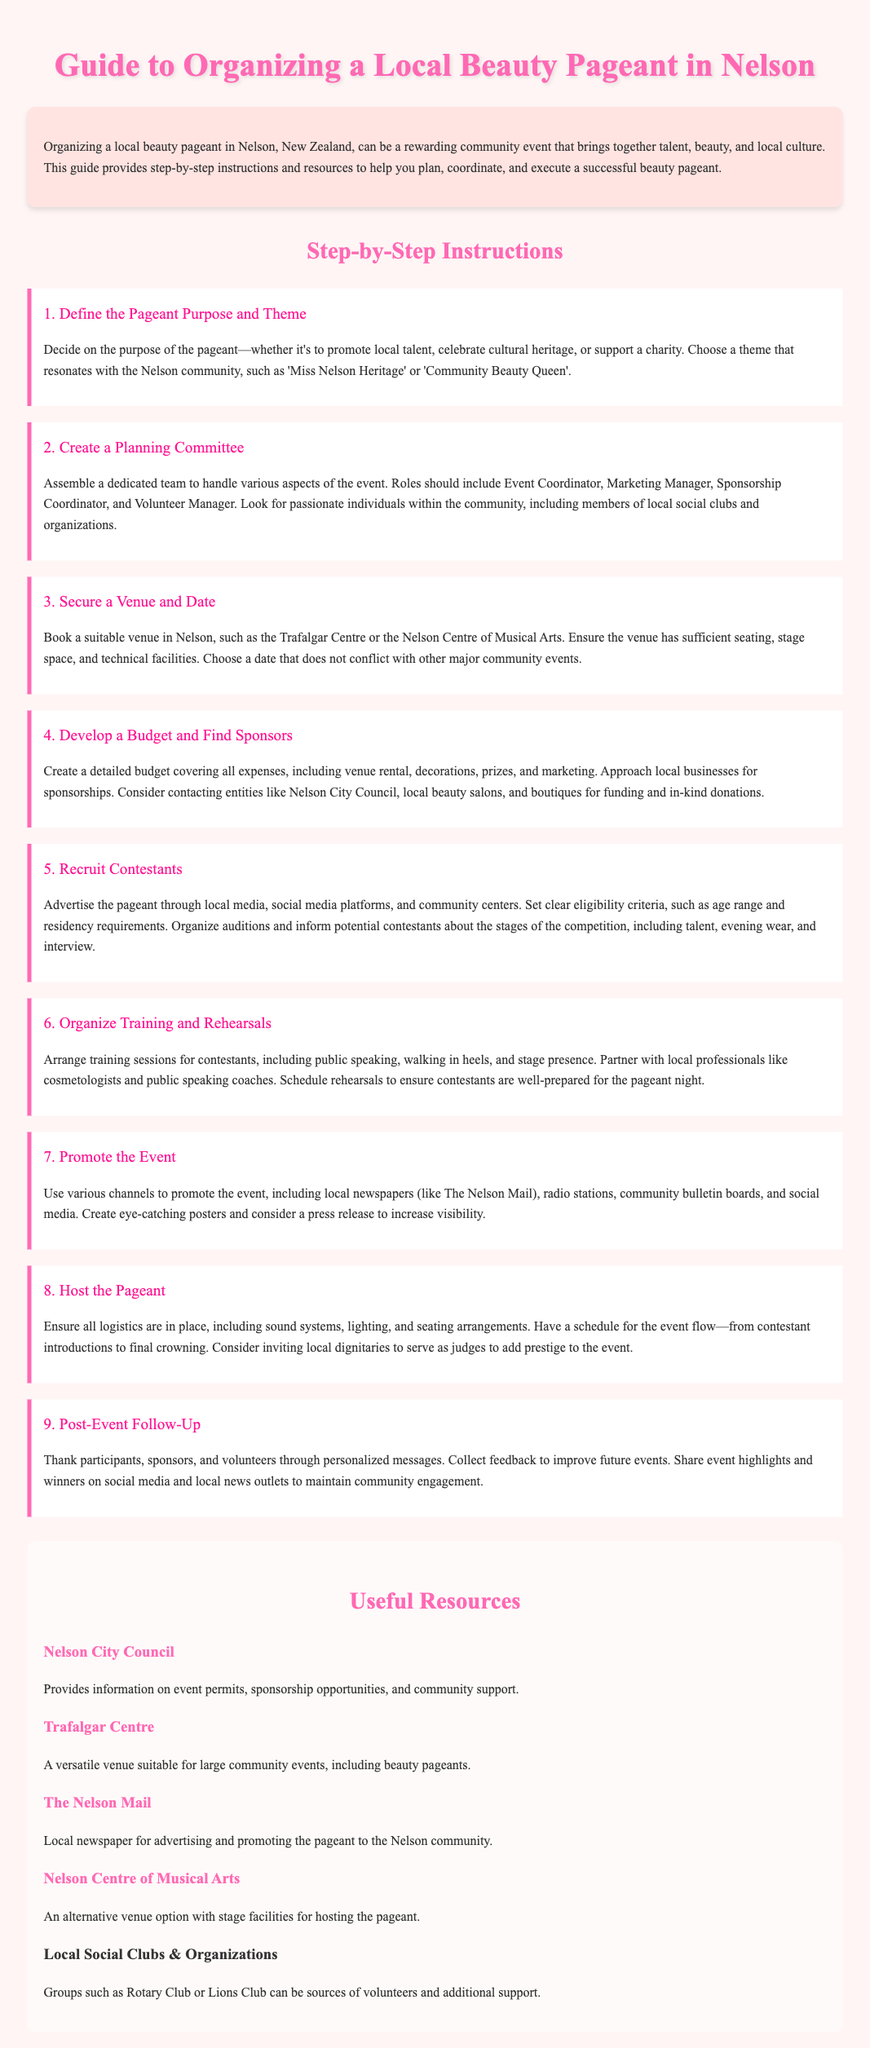What is the first step in organizing a beauty pageant? The first step is to define the pageant purpose and theme.
Answer: Define the Pageant Purpose and Theme Which venue is suggested for hosting the pageant? The document suggests venues like the Trafalgar Centre or the Nelson Centre of Musical Arts.
Answer: Trafalgar Centre How many roles should be included in the planning committee? The document explicitly mentions roles but doesn't specify a number; however, multiple roles are suggested.
Answer: Multiple roles What should be included in the budget? The budget should cover expenses such as venue rental, decorations, prizes, and marketing.
Answer: Venue rental, decorations, prizes, and marketing What is a recommended way to recruit contestants? Advertising through local media, social media platforms, and community centers is recommended.
Answer: Local media and social media Who can provide additional support for organizing the pageant? Local social clubs and organizations, such as Rotary Club or Lions Club, can provide support.
Answer: Rotary Club or Lions Club What is the purpose of sending personalized messages after the event? The purpose is to thank participants, sponsors, and volunteers and gather feedback.
Answer: Thank participants, sponsors, and volunteers How can the event be promoted effectively? Various channels such as local newspapers, radio stations, and social media should be used.
Answer: Local newspapers and social media What type of training should contestants receive? Contestants should receive training in public speaking, walking in heels, and stage presence.
Answer: Public speaking and stage presence 